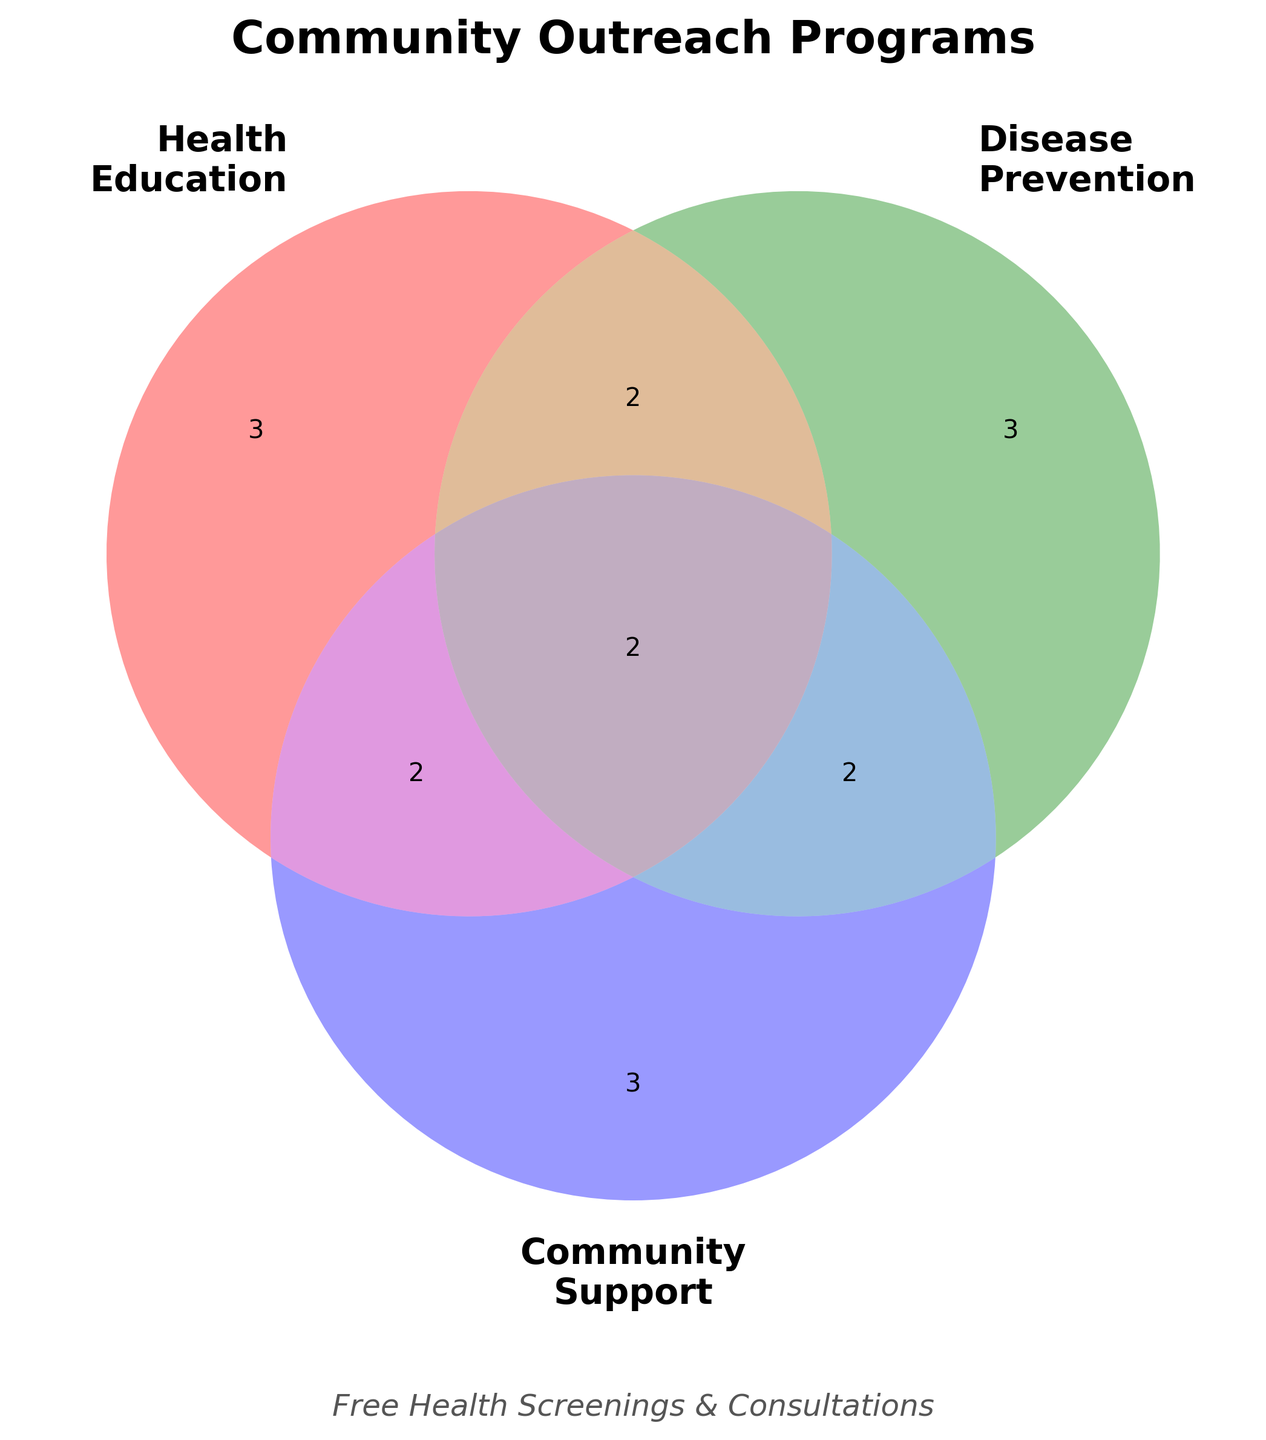What is the title of the Venn Diagram? The title is usually at the top of the figure. The title helps summarize the figure's content at a glance.
Answer: Community Outreach Programs How many unique areas focus on 'Health Education'? Look for the section labeled 'Health Education' and count the number of unique programs listed in its segment.
Answer: 3 Which area does 'Vaccination drives' belong to? Locate the section of the diagram that represents 'Disease Prevention' to see if 'Vaccination drives' is listed there.
Answer: Disease Prevention How many programs are common to all three focus areas? Identify the intersection point where 'Health Education', 'Disease Prevention', and 'Community Support' overlap and count the programs listed there.
Answer: 2 Which segment includes 'Support groups'? Look at the sections related to 'Community Support' to find 'Support groups'.
Answer: Community Support What is the combined number of programs for 'Health Education' and 'Community Support' only? Identify the programs listed in the overlapping area for 'Health Education' and 'Community Support' only, then count them.
Answer: 2 Compare the number of programs in 'Disease Prevention' and 'Community Support'. Which one has more? Count the programs in the 'Disease Prevention' segment and compare them with the count in the 'Community Support' segment.
Answer: Disease Prevention Are there more programs in 'Health Education' alone or in 'Health Education and Disease Prevention'? Count the programs in 'Health Education' alone and compare it to those in the intersection of 'Health Education and Disease Prevention'.
Answer: Health Education and Disease Prevention Which programs fall under the intersection of 'Disease Prevention' and 'Community Support'? Find the overlapping section of the Venn Diagram that covers both 'Disease Prevention' and 'Community Support' and list the programs there.
Answer: Cancer support; Substance abuse prevention 